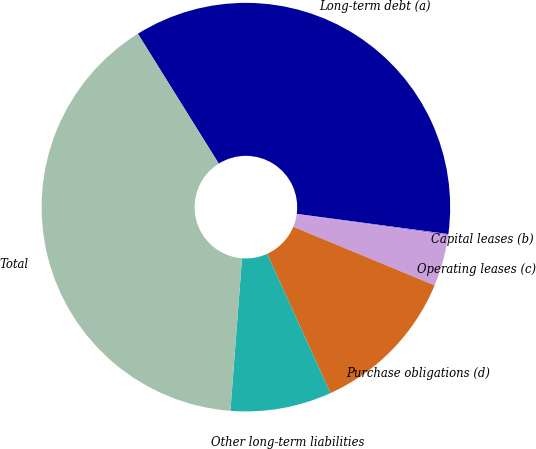Convert chart. <chart><loc_0><loc_0><loc_500><loc_500><pie_chart><fcel>Long-term debt (a)<fcel>Capital leases (b)<fcel>Operating leases (c)<fcel>Purchase obligations (d)<fcel>Other long-term liabilities<fcel>Total<nl><fcel>35.97%<fcel>0.1%<fcel>4.05%<fcel>11.95%<fcel>8.0%<fcel>39.92%<nl></chart> 